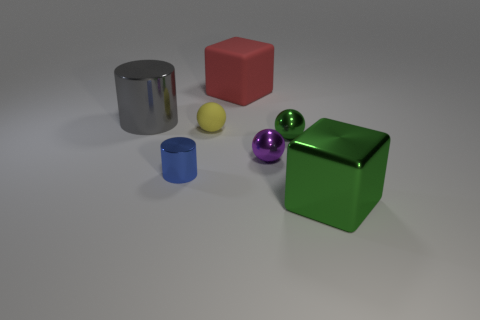Subtract all small metal balls. How many balls are left? 1 Subtract all red blocks. How many blocks are left? 1 Subtract 3 balls. How many balls are left? 0 Add 3 tiny metallic cubes. How many objects exist? 10 Subtract all metallic spheres. Subtract all green cubes. How many objects are left? 4 Add 1 red rubber blocks. How many red rubber blocks are left? 2 Add 6 large gray blocks. How many large gray blocks exist? 6 Subtract 0 gray spheres. How many objects are left? 7 Subtract all spheres. How many objects are left? 4 Subtract all red spheres. Subtract all green cubes. How many spheres are left? 3 